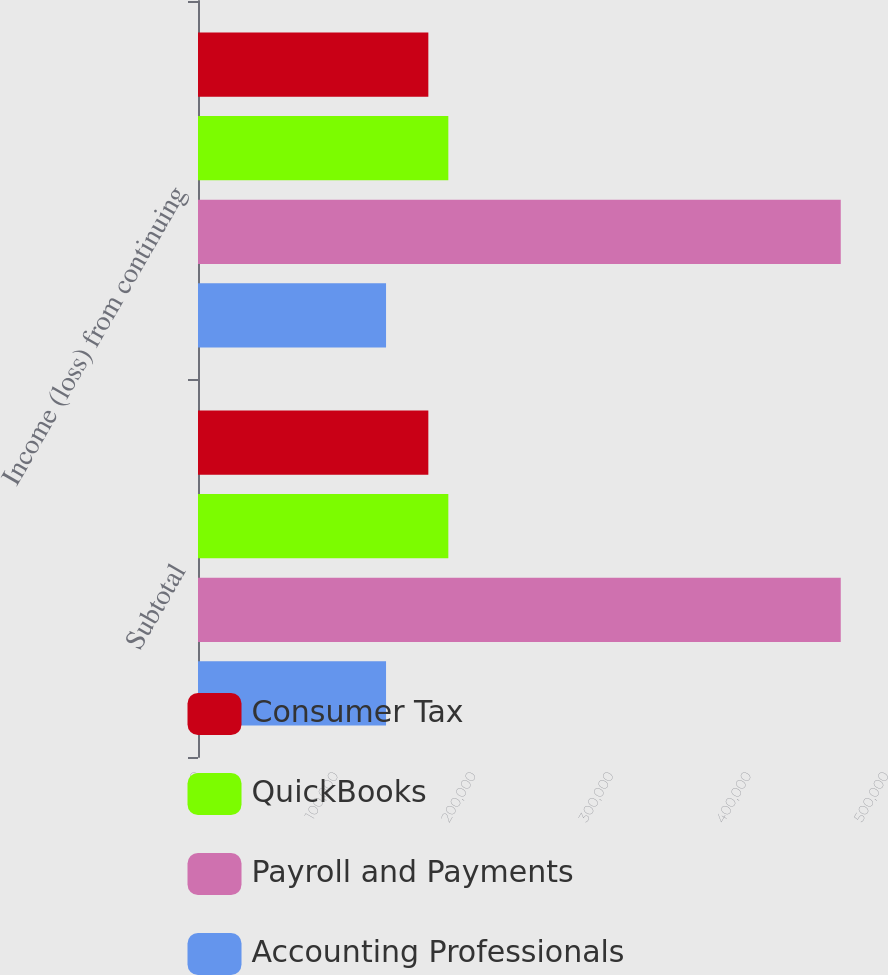<chart> <loc_0><loc_0><loc_500><loc_500><stacked_bar_chart><ecel><fcel>Subtotal<fcel>Income (loss) from continuing<nl><fcel>Consumer Tax<fcel>167397<fcel>167397<nl><fcel>QuickBooks<fcel>181927<fcel>181927<nl><fcel>Payroll and Payments<fcel>467118<fcel>467118<nl><fcel>Accounting Professionals<fcel>136663<fcel>136663<nl></chart> 